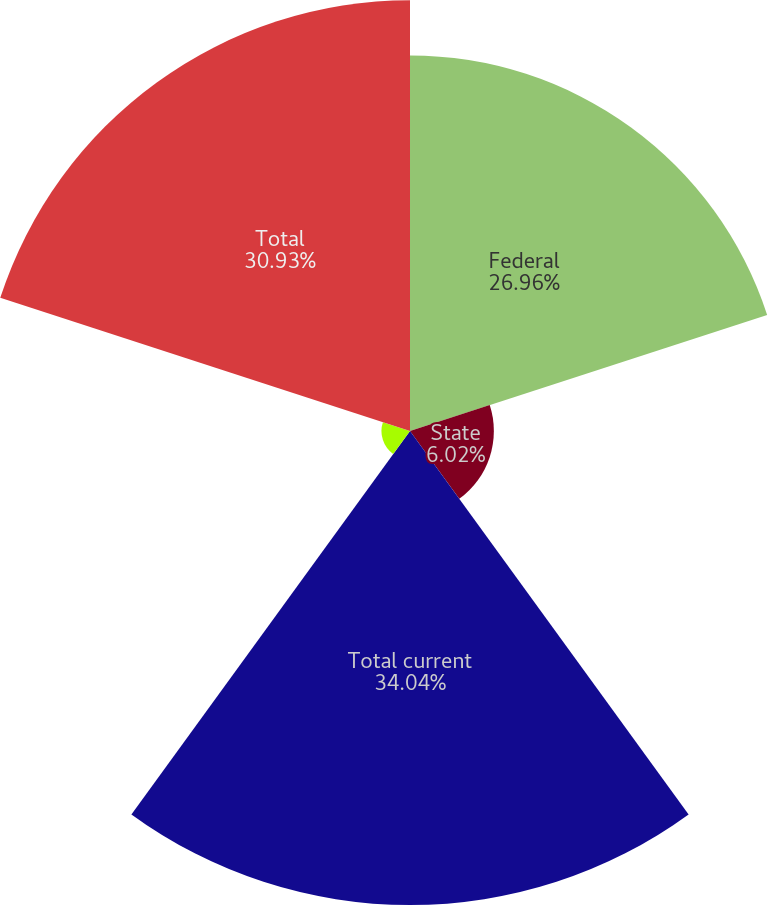<chart> <loc_0><loc_0><loc_500><loc_500><pie_chart><fcel>Federal<fcel>State<fcel>Total current<fcel>Total deferred<fcel>Total<nl><fcel>26.96%<fcel>6.02%<fcel>34.03%<fcel>2.05%<fcel>30.93%<nl></chart> 